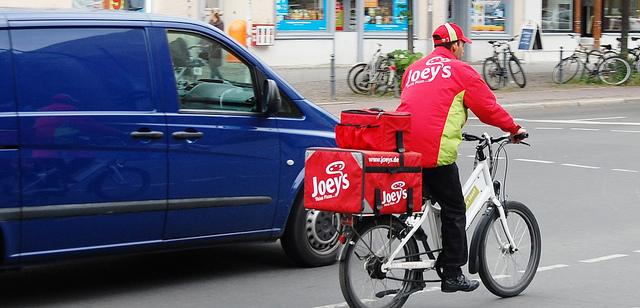What boy is watching? Is he riding or stop for someone?
Write a very short answer. Riding. Who does the man work for?
Give a very brief answer. Joey's. Is the boy next to a white car?
Concise answer only. No. 